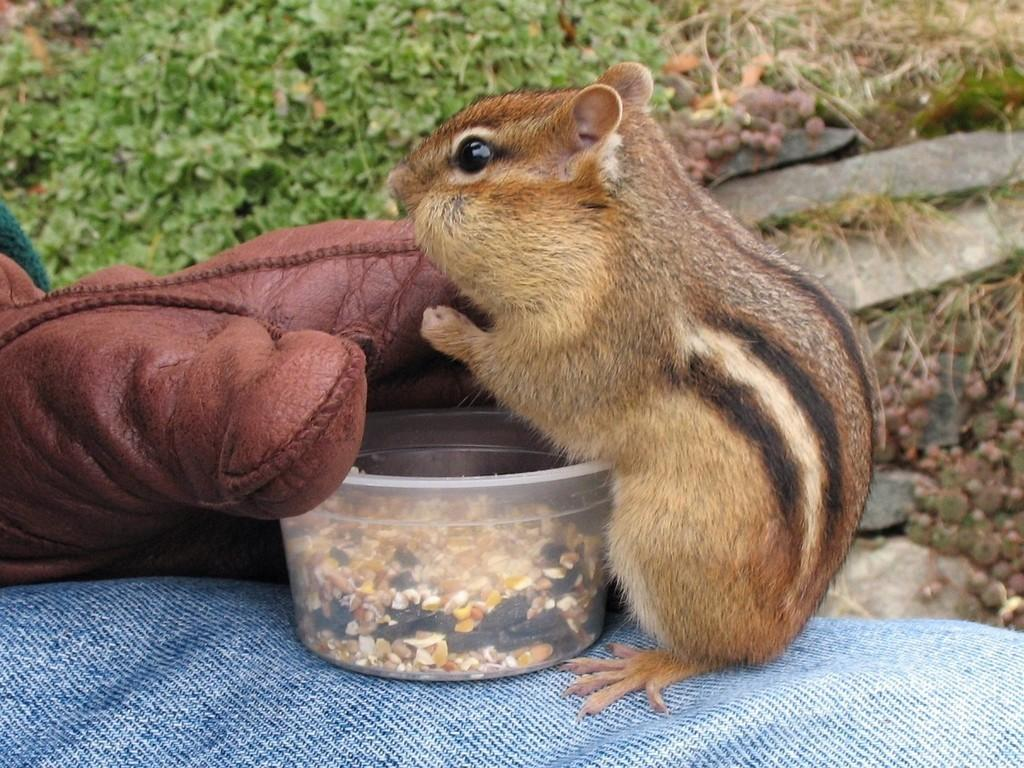What animal can be seen in the image? There is a squirrel in the image. What is in the bowl that is visible in the image? There is a bowl with a food item in the image. What is the bowl placed on? The bowl is placed on a cloth. What type of clothing item is on the left side of the image? There is a hand glove on the left side of the image. What type of natural environment is visible in the background of the image? There is grass in the background of the image. What type of basket is visible in the image? There is no basket present in the image. What scientific theory is being discussed in the image? There is no discussion of a scientific theory in the image. 